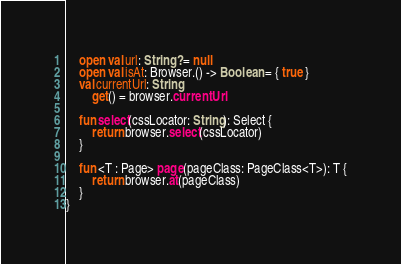<code> <loc_0><loc_0><loc_500><loc_500><_Kotlin_>
    open val url: String? = null
    open val isAt: Browser.() -> Boolean = { true }
    val currentUrl: String
        get() = browser.currentUrl

    fun select(cssLocator: String): Select {
        return browser.select(cssLocator)
    }

    fun <T : Page> page(pageClass: PageClass<T>): T {
        return browser.at(pageClass)
    }
}
</code> 